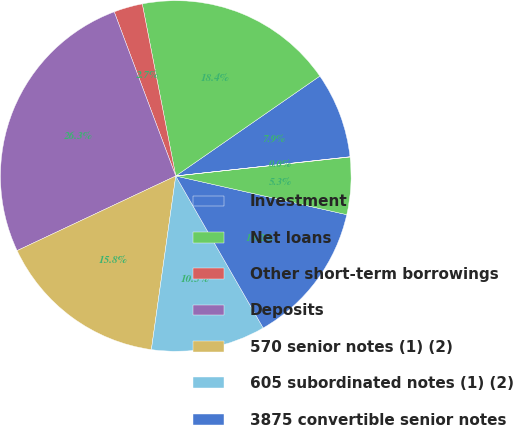Convert chart to OTSL. <chart><loc_0><loc_0><loc_500><loc_500><pie_chart><fcel>Investment<fcel>Net loans<fcel>Other short-term borrowings<fcel>Deposits<fcel>570 senior notes (1) (2)<fcel>605 subordinated notes (1) (2)<fcel>3875 convertible senior notes<fcel>70 junior subordinated<fcel>Other long-term debt<nl><fcel>7.9%<fcel>18.41%<fcel>2.65%<fcel>26.29%<fcel>15.78%<fcel>10.53%<fcel>13.15%<fcel>5.27%<fcel>0.02%<nl></chart> 